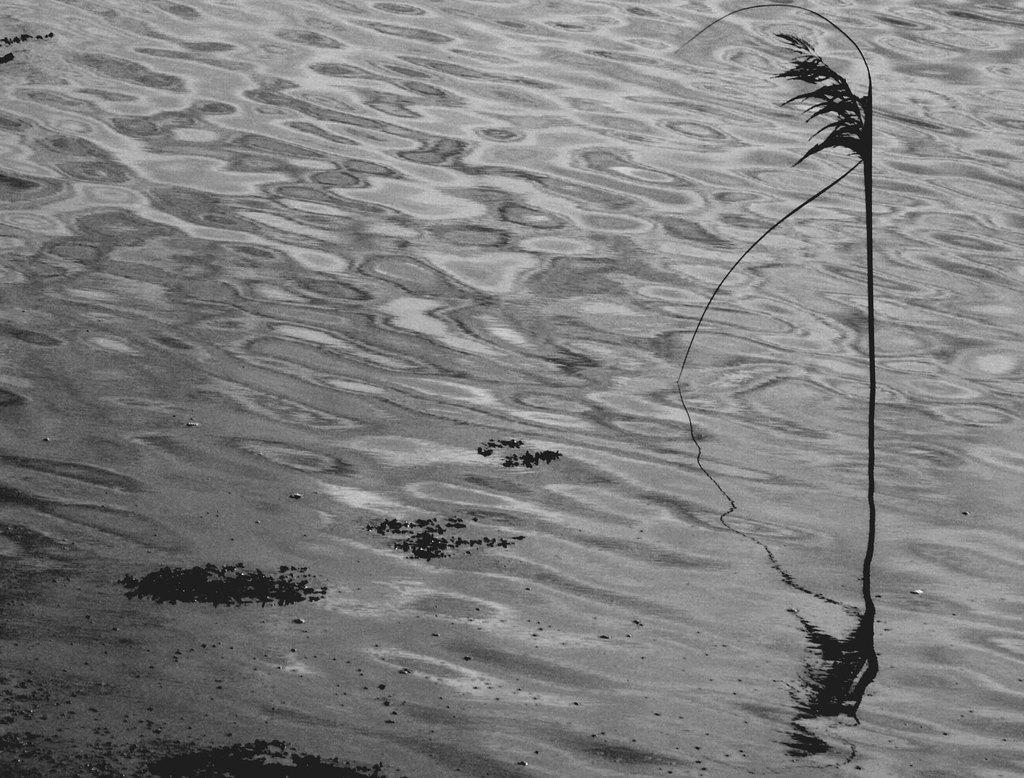Describe this image in one or two sentences. Here there is a plant in the water. 